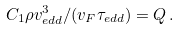Convert formula to latex. <formula><loc_0><loc_0><loc_500><loc_500>C _ { 1 } \rho v _ { e d d } ^ { 3 } / ( v _ { F } \tau _ { e d d } ) = Q \, .</formula> 